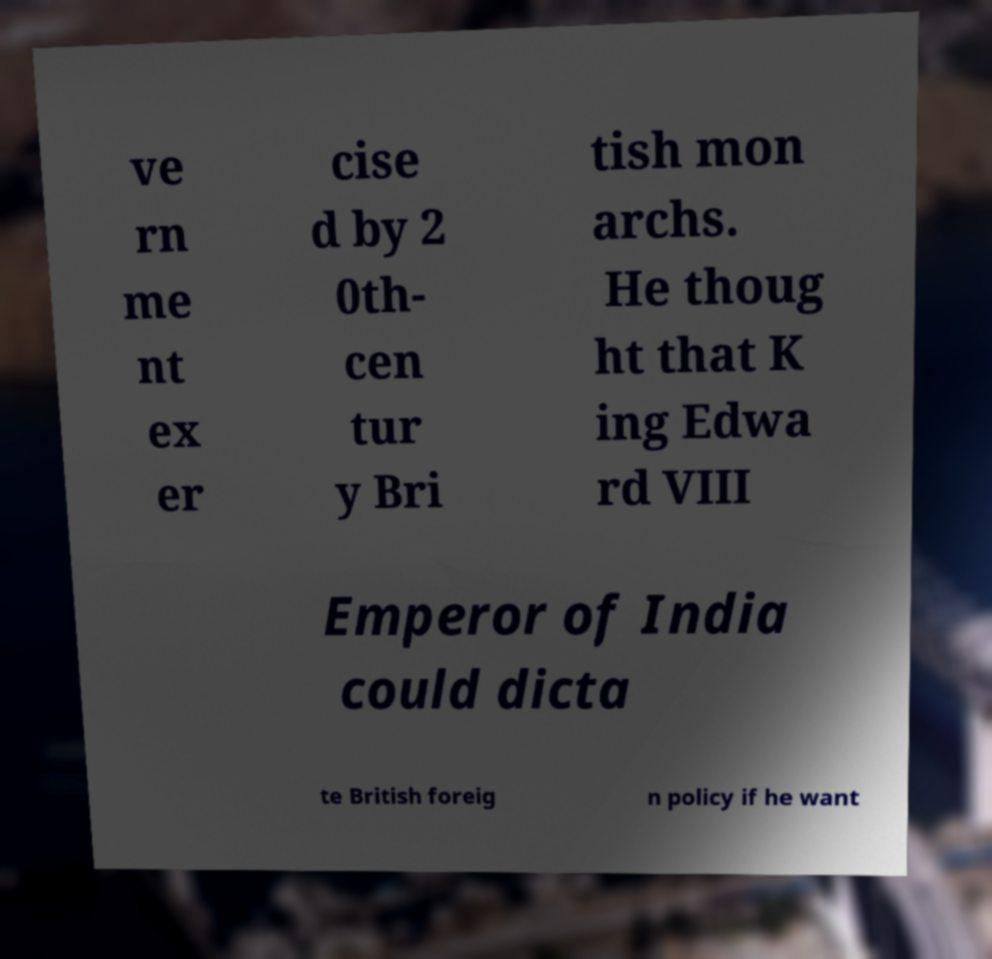Can you accurately transcribe the text from the provided image for me? ve rn me nt ex er cise d by 2 0th- cen tur y Bri tish mon archs. He thoug ht that K ing Edwa rd VIII Emperor of India could dicta te British foreig n policy if he want 